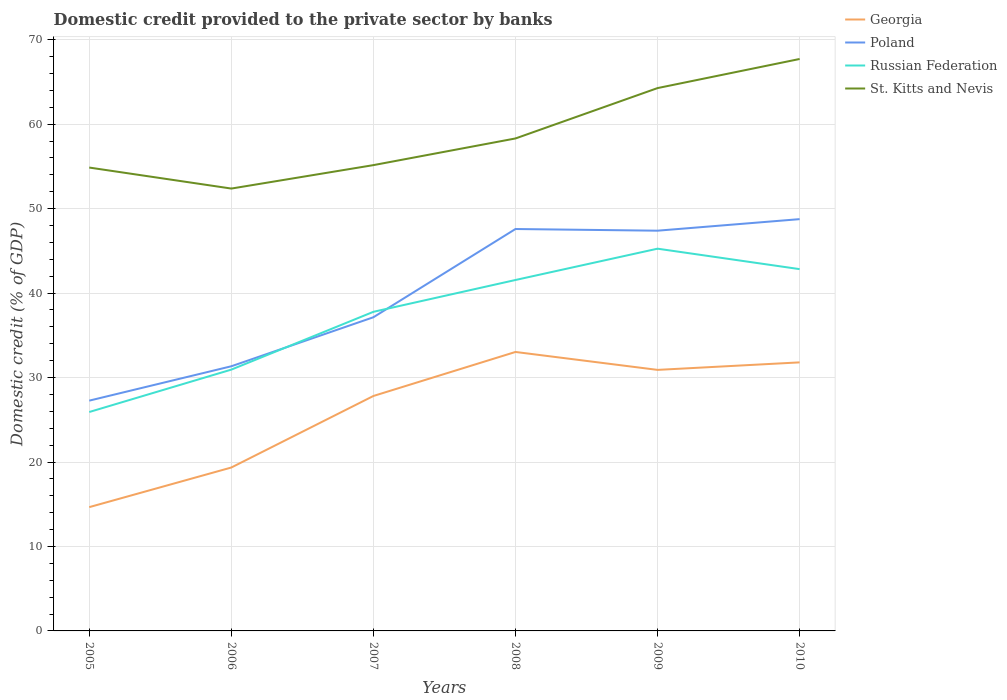Is the number of lines equal to the number of legend labels?
Your answer should be compact. Yes. Across all years, what is the maximum domestic credit provided to the private sector by banks in Georgia?
Provide a short and direct response. 14.66. In which year was the domestic credit provided to the private sector by banks in Poland maximum?
Make the answer very short. 2005. What is the total domestic credit provided to the private sector by banks in Georgia in the graph?
Keep it short and to the point. -13.16. What is the difference between the highest and the second highest domestic credit provided to the private sector by banks in St. Kitts and Nevis?
Keep it short and to the point. 15.34. What is the difference between two consecutive major ticks on the Y-axis?
Offer a terse response. 10. Are the values on the major ticks of Y-axis written in scientific E-notation?
Make the answer very short. No. Does the graph contain any zero values?
Your response must be concise. No. How are the legend labels stacked?
Offer a very short reply. Vertical. What is the title of the graph?
Your answer should be very brief. Domestic credit provided to the private sector by banks. Does "Croatia" appear as one of the legend labels in the graph?
Ensure brevity in your answer.  No. What is the label or title of the Y-axis?
Provide a succinct answer. Domestic credit (% of GDP). What is the Domestic credit (% of GDP) of Georgia in 2005?
Offer a terse response. 14.66. What is the Domestic credit (% of GDP) in Poland in 2005?
Keep it short and to the point. 27.27. What is the Domestic credit (% of GDP) in Russian Federation in 2005?
Offer a very short reply. 25.92. What is the Domestic credit (% of GDP) in St. Kitts and Nevis in 2005?
Ensure brevity in your answer.  54.86. What is the Domestic credit (% of GDP) in Georgia in 2006?
Make the answer very short. 19.35. What is the Domestic credit (% of GDP) in Poland in 2006?
Provide a short and direct response. 31.33. What is the Domestic credit (% of GDP) of Russian Federation in 2006?
Make the answer very short. 30.94. What is the Domestic credit (% of GDP) of St. Kitts and Nevis in 2006?
Ensure brevity in your answer.  52.38. What is the Domestic credit (% of GDP) of Georgia in 2007?
Give a very brief answer. 27.82. What is the Domestic credit (% of GDP) of Poland in 2007?
Your answer should be compact. 37.14. What is the Domestic credit (% of GDP) in Russian Federation in 2007?
Your answer should be compact. 37.78. What is the Domestic credit (% of GDP) in St. Kitts and Nevis in 2007?
Keep it short and to the point. 55.15. What is the Domestic credit (% of GDP) of Georgia in 2008?
Your response must be concise. 33.03. What is the Domestic credit (% of GDP) of Poland in 2008?
Offer a terse response. 47.59. What is the Domestic credit (% of GDP) of Russian Federation in 2008?
Offer a very short reply. 41.55. What is the Domestic credit (% of GDP) in St. Kitts and Nevis in 2008?
Your answer should be very brief. 58.31. What is the Domestic credit (% of GDP) of Georgia in 2009?
Your answer should be compact. 30.91. What is the Domestic credit (% of GDP) of Poland in 2009?
Your response must be concise. 47.39. What is the Domestic credit (% of GDP) in Russian Federation in 2009?
Make the answer very short. 45.26. What is the Domestic credit (% of GDP) of St. Kitts and Nevis in 2009?
Ensure brevity in your answer.  64.27. What is the Domestic credit (% of GDP) in Georgia in 2010?
Give a very brief answer. 31.8. What is the Domestic credit (% of GDP) of Poland in 2010?
Your answer should be very brief. 48.75. What is the Domestic credit (% of GDP) of Russian Federation in 2010?
Your answer should be very brief. 42.84. What is the Domestic credit (% of GDP) of St. Kitts and Nevis in 2010?
Offer a very short reply. 67.72. Across all years, what is the maximum Domestic credit (% of GDP) in Georgia?
Your answer should be very brief. 33.03. Across all years, what is the maximum Domestic credit (% of GDP) of Poland?
Provide a succinct answer. 48.75. Across all years, what is the maximum Domestic credit (% of GDP) in Russian Federation?
Ensure brevity in your answer.  45.26. Across all years, what is the maximum Domestic credit (% of GDP) in St. Kitts and Nevis?
Make the answer very short. 67.72. Across all years, what is the minimum Domestic credit (% of GDP) in Georgia?
Keep it short and to the point. 14.66. Across all years, what is the minimum Domestic credit (% of GDP) in Poland?
Provide a short and direct response. 27.27. Across all years, what is the minimum Domestic credit (% of GDP) in Russian Federation?
Give a very brief answer. 25.92. Across all years, what is the minimum Domestic credit (% of GDP) of St. Kitts and Nevis?
Your answer should be very brief. 52.38. What is the total Domestic credit (% of GDP) of Georgia in the graph?
Provide a succinct answer. 157.55. What is the total Domestic credit (% of GDP) of Poland in the graph?
Provide a short and direct response. 239.47. What is the total Domestic credit (% of GDP) in Russian Federation in the graph?
Offer a terse response. 224.28. What is the total Domestic credit (% of GDP) in St. Kitts and Nevis in the graph?
Give a very brief answer. 352.69. What is the difference between the Domestic credit (% of GDP) in Georgia in 2005 and that in 2006?
Your answer should be compact. -4.69. What is the difference between the Domestic credit (% of GDP) in Poland in 2005 and that in 2006?
Your answer should be very brief. -4.07. What is the difference between the Domestic credit (% of GDP) of Russian Federation in 2005 and that in 2006?
Ensure brevity in your answer.  -5.02. What is the difference between the Domestic credit (% of GDP) of St. Kitts and Nevis in 2005 and that in 2006?
Offer a very short reply. 2.49. What is the difference between the Domestic credit (% of GDP) in Georgia in 2005 and that in 2007?
Provide a short and direct response. -13.16. What is the difference between the Domestic credit (% of GDP) of Poland in 2005 and that in 2007?
Your response must be concise. -9.87. What is the difference between the Domestic credit (% of GDP) of Russian Federation in 2005 and that in 2007?
Offer a very short reply. -11.86. What is the difference between the Domestic credit (% of GDP) in St. Kitts and Nevis in 2005 and that in 2007?
Give a very brief answer. -0.29. What is the difference between the Domestic credit (% of GDP) in Georgia in 2005 and that in 2008?
Your response must be concise. -18.37. What is the difference between the Domestic credit (% of GDP) of Poland in 2005 and that in 2008?
Offer a very short reply. -20.32. What is the difference between the Domestic credit (% of GDP) of Russian Federation in 2005 and that in 2008?
Provide a succinct answer. -15.63. What is the difference between the Domestic credit (% of GDP) in St. Kitts and Nevis in 2005 and that in 2008?
Keep it short and to the point. -3.44. What is the difference between the Domestic credit (% of GDP) in Georgia in 2005 and that in 2009?
Make the answer very short. -16.25. What is the difference between the Domestic credit (% of GDP) in Poland in 2005 and that in 2009?
Offer a terse response. -20.12. What is the difference between the Domestic credit (% of GDP) in Russian Federation in 2005 and that in 2009?
Ensure brevity in your answer.  -19.34. What is the difference between the Domestic credit (% of GDP) in St. Kitts and Nevis in 2005 and that in 2009?
Give a very brief answer. -9.41. What is the difference between the Domestic credit (% of GDP) in Georgia in 2005 and that in 2010?
Keep it short and to the point. -17.14. What is the difference between the Domestic credit (% of GDP) of Poland in 2005 and that in 2010?
Give a very brief answer. -21.49. What is the difference between the Domestic credit (% of GDP) of Russian Federation in 2005 and that in 2010?
Provide a short and direct response. -16.92. What is the difference between the Domestic credit (% of GDP) in St. Kitts and Nevis in 2005 and that in 2010?
Give a very brief answer. -12.85. What is the difference between the Domestic credit (% of GDP) of Georgia in 2006 and that in 2007?
Your response must be concise. -8.47. What is the difference between the Domestic credit (% of GDP) of Poland in 2006 and that in 2007?
Offer a terse response. -5.8. What is the difference between the Domestic credit (% of GDP) of Russian Federation in 2006 and that in 2007?
Provide a short and direct response. -6.84. What is the difference between the Domestic credit (% of GDP) of St. Kitts and Nevis in 2006 and that in 2007?
Your answer should be very brief. -2.77. What is the difference between the Domestic credit (% of GDP) of Georgia in 2006 and that in 2008?
Provide a short and direct response. -13.68. What is the difference between the Domestic credit (% of GDP) in Poland in 2006 and that in 2008?
Provide a succinct answer. -16.25. What is the difference between the Domestic credit (% of GDP) in Russian Federation in 2006 and that in 2008?
Your answer should be very brief. -10.61. What is the difference between the Domestic credit (% of GDP) of St. Kitts and Nevis in 2006 and that in 2008?
Your answer should be very brief. -5.93. What is the difference between the Domestic credit (% of GDP) of Georgia in 2006 and that in 2009?
Keep it short and to the point. -11.56. What is the difference between the Domestic credit (% of GDP) of Poland in 2006 and that in 2009?
Provide a short and direct response. -16.05. What is the difference between the Domestic credit (% of GDP) of Russian Federation in 2006 and that in 2009?
Make the answer very short. -14.32. What is the difference between the Domestic credit (% of GDP) of St. Kitts and Nevis in 2006 and that in 2009?
Your answer should be very brief. -11.9. What is the difference between the Domestic credit (% of GDP) of Georgia in 2006 and that in 2010?
Keep it short and to the point. -12.45. What is the difference between the Domestic credit (% of GDP) of Poland in 2006 and that in 2010?
Your answer should be compact. -17.42. What is the difference between the Domestic credit (% of GDP) of Russian Federation in 2006 and that in 2010?
Ensure brevity in your answer.  -11.9. What is the difference between the Domestic credit (% of GDP) of St. Kitts and Nevis in 2006 and that in 2010?
Provide a succinct answer. -15.34. What is the difference between the Domestic credit (% of GDP) of Georgia in 2007 and that in 2008?
Make the answer very short. -5.21. What is the difference between the Domestic credit (% of GDP) in Poland in 2007 and that in 2008?
Your answer should be very brief. -10.45. What is the difference between the Domestic credit (% of GDP) in Russian Federation in 2007 and that in 2008?
Ensure brevity in your answer.  -3.77. What is the difference between the Domestic credit (% of GDP) of St. Kitts and Nevis in 2007 and that in 2008?
Your answer should be very brief. -3.16. What is the difference between the Domestic credit (% of GDP) in Georgia in 2007 and that in 2009?
Your answer should be compact. -3.09. What is the difference between the Domestic credit (% of GDP) of Poland in 2007 and that in 2009?
Your response must be concise. -10.25. What is the difference between the Domestic credit (% of GDP) in Russian Federation in 2007 and that in 2009?
Your answer should be very brief. -7.48. What is the difference between the Domestic credit (% of GDP) of St. Kitts and Nevis in 2007 and that in 2009?
Your answer should be compact. -9.12. What is the difference between the Domestic credit (% of GDP) in Georgia in 2007 and that in 2010?
Provide a succinct answer. -3.98. What is the difference between the Domestic credit (% of GDP) of Poland in 2007 and that in 2010?
Provide a succinct answer. -11.62. What is the difference between the Domestic credit (% of GDP) of Russian Federation in 2007 and that in 2010?
Your answer should be compact. -5.05. What is the difference between the Domestic credit (% of GDP) in St. Kitts and Nevis in 2007 and that in 2010?
Offer a very short reply. -12.57. What is the difference between the Domestic credit (% of GDP) in Georgia in 2008 and that in 2009?
Offer a very short reply. 2.12. What is the difference between the Domestic credit (% of GDP) in Poland in 2008 and that in 2009?
Provide a succinct answer. 0.2. What is the difference between the Domestic credit (% of GDP) of Russian Federation in 2008 and that in 2009?
Offer a very short reply. -3.71. What is the difference between the Domestic credit (% of GDP) of St. Kitts and Nevis in 2008 and that in 2009?
Offer a very short reply. -5.96. What is the difference between the Domestic credit (% of GDP) in Georgia in 2008 and that in 2010?
Offer a very short reply. 1.23. What is the difference between the Domestic credit (% of GDP) in Poland in 2008 and that in 2010?
Offer a very short reply. -1.17. What is the difference between the Domestic credit (% of GDP) of Russian Federation in 2008 and that in 2010?
Make the answer very short. -1.29. What is the difference between the Domestic credit (% of GDP) of St. Kitts and Nevis in 2008 and that in 2010?
Offer a very short reply. -9.41. What is the difference between the Domestic credit (% of GDP) of Georgia in 2009 and that in 2010?
Keep it short and to the point. -0.89. What is the difference between the Domestic credit (% of GDP) of Poland in 2009 and that in 2010?
Provide a succinct answer. -1.37. What is the difference between the Domestic credit (% of GDP) in Russian Federation in 2009 and that in 2010?
Give a very brief answer. 2.42. What is the difference between the Domestic credit (% of GDP) of St. Kitts and Nevis in 2009 and that in 2010?
Ensure brevity in your answer.  -3.45. What is the difference between the Domestic credit (% of GDP) in Georgia in 2005 and the Domestic credit (% of GDP) in Poland in 2006?
Offer a very short reply. -16.68. What is the difference between the Domestic credit (% of GDP) in Georgia in 2005 and the Domestic credit (% of GDP) in Russian Federation in 2006?
Ensure brevity in your answer.  -16.28. What is the difference between the Domestic credit (% of GDP) of Georgia in 2005 and the Domestic credit (% of GDP) of St. Kitts and Nevis in 2006?
Offer a very short reply. -37.72. What is the difference between the Domestic credit (% of GDP) in Poland in 2005 and the Domestic credit (% of GDP) in Russian Federation in 2006?
Provide a succinct answer. -3.67. What is the difference between the Domestic credit (% of GDP) of Poland in 2005 and the Domestic credit (% of GDP) of St. Kitts and Nevis in 2006?
Give a very brief answer. -25.11. What is the difference between the Domestic credit (% of GDP) of Russian Federation in 2005 and the Domestic credit (% of GDP) of St. Kitts and Nevis in 2006?
Keep it short and to the point. -26.46. What is the difference between the Domestic credit (% of GDP) in Georgia in 2005 and the Domestic credit (% of GDP) in Poland in 2007?
Your answer should be compact. -22.48. What is the difference between the Domestic credit (% of GDP) of Georgia in 2005 and the Domestic credit (% of GDP) of Russian Federation in 2007?
Provide a succinct answer. -23.13. What is the difference between the Domestic credit (% of GDP) in Georgia in 2005 and the Domestic credit (% of GDP) in St. Kitts and Nevis in 2007?
Your answer should be very brief. -40.49. What is the difference between the Domestic credit (% of GDP) in Poland in 2005 and the Domestic credit (% of GDP) in Russian Federation in 2007?
Give a very brief answer. -10.52. What is the difference between the Domestic credit (% of GDP) of Poland in 2005 and the Domestic credit (% of GDP) of St. Kitts and Nevis in 2007?
Offer a terse response. -27.89. What is the difference between the Domestic credit (% of GDP) in Russian Federation in 2005 and the Domestic credit (% of GDP) in St. Kitts and Nevis in 2007?
Your answer should be very brief. -29.23. What is the difference between the Domestic credit (% of GDP) of Georgia in 2005 and the Domestic credit (% of GDP) of Poland in 2008?
Your response must be concise. -32.93. What is the difference between the Domestic credit (% of GDP) in Georgia in 2005 and the Domestic credit (% of GDP) in Russian Federation in 2008?
Make the answer very short. -26.9. What is the difference between the Domestic credit (% of GDP) in Georgia in 2005 and the Domestic credit (% of GDP) in St. Kitts and Nevis in 2008?
Offer a very short reply. -43.65. What is the difference between the Domestic credit (% of GDP) in Poland in 2005 and the Domestic credit (% of GDP) in Russian Federation in 2008?
Your response must be concise. -14.29. What is the difference between the Domestic credit (% of GDP) of Poland in 2005 and the Domestic credit (% of GDP) of St. Kitts and Nevis in 2008?
Keep it short and to the point. -31.04. What is the difference between the Domestic credit (% of GDP) in Russian Federation in 2005 and the Domestic credit (% of GDP) in St. Kitts and Nevis in 2008?
Make the answer very short. -32.39. What is the difference between the Domestic credit (% of GDP) of Georgia in 2005 and the Domestic credit (% of GDP) of Poland in 2009?
Your response must be concise. -32.73. What is the difference between the Domestic credit (% of GDP) in Georgia in 2005 and the Domestic credit (% of GDP) in Russian Federation in 2009?
Offer a very short reply. -30.6. What is the difference between the Domestic credit (% of GDP) of Georgia in 2005 and the Domestic credit (% of GDP) of St. Kitts and Nevis in 2009?
Your answer should be compact. -49.62. What is the difference between the Domestic credit (% of GDP) in Poland in 2005 and the Domestic credit (% of GDP) in Russian Federation in 2009?
Provide a short and direct response. -17.99. What is the difference between the Domestic credit (% of GDP) of Poland in 2005 and the Domestic credit (% of GDP) of St. Kitts and Nevis in 2009?
Your answer should be compact. -37.01. What is the difference between the Domestic credit (% of GDP) of Russian Federation in 2005 and the Domestic credit (% of GDP) of St. Kitts and Nevis in 2009?
Offer a terse response. -38.35. What is the difference between the Domestic credit (% of GDP) in Georgia in 2005 and the Domestic credit (% of GDP) in Poland in 2010?
Ensure brevity in your answer.  -34.1. What is the difference between the Domestic credit (% of GDP) of Georgia in 2005 and the Domestic credit (% of GDP) of Russian Federation in 2010?
Your response must be concise. -28.18. What is the difference between the Domestic credit (% of GDP) of Georgia in 2005 and the Domestic credit (% of GDP) of St. Kitts and Nevis in 2010?
Offer a very short reply. -53.06. What is the difference between the Domestic credit (% of GDP) of Poland in 2005 and the Domestic credit (% of GDP) of Russian Federation in 2010?
Offer a terse response. -15.57. What is the difference between the Domestic credit (% of GDP) in Poland in 2005 and the Domestic credit (% of GDP) in St. Kitts and Nevis in 2010?
Your answer should be very brief. -40.45. What is the difference between the Domestic credit (% of GDP) in Russian Federation in 2005 and the Domestic credit (% of GDP) in St. Kitts and Nevis in 2010?
Your answer should be very brief. -41.8. What is the difference between the Domestic credit (% of GDP) of Georgia in 2006 and the Domestic credit (% of GDP) of Poland in 2007?
Give a very brief answer. -17.79. What is the difference between the Domestic credit (% of GDP) of Georgia in 2006 and the Domestic credit (% of GDP) of Russian Federation in 2007?
Ensure brevity in your answer.  -18.43. What is the difference between the Domestic credit (% of GDP) of Georgia in 2006 and the Domestic credit (% of GDP) of St. Kitts and Nevis in 2007?
Give a very brief answer. -35.8. What is the difference between the Domestic credit (% of GDP) of Poland in 2006 and the Domestic credit (% of GDP) of Russian Federation in 2007?
Ensure brevity in your answer.  -6.45. What is the difference between the Domestic credit (% of GDP) in Poland in 2006 and the Domestic credit (% of GDP) in St. Kitts and Nevis in 2007?
Offer a very short reply. -23.82. What is the difference between the Domestic credit (% of GDP) of Russian Federation in 2006 and the Domestic credit (% of GDP) of St. Kitts and Nevis in 2007?
Provide a short and direct response. -24.21. What is the difference between the Domestic credit (% of GDP) of Georgia in 2006 and the Domestic credit (% of GDP) of Poland in 2008?
Your answer should be very brief. -28.24. What is the difference between the Domestic credit (% of GDP) in Georgia in 2006 and the Domestic credit (% of GDP) in Russian Federation in 2008?
Offer a very short reply. -22.2. What is the difference between the Domestic credit (% of GDP) in Georgia in 2006 and the Domestic credit (% of GDP) in St. Kitts and Nevis in 2008?
Offer a terse response. -38.96. What is the difference between the Domestic credit (% of GDP) of Poland in 2006 and the Domestic credit (% of GDP) of Russian Federation in 2008?
Ensure brevity in your answer.  -10.22. What is the difference between the Domestic credit (% of GDP) of Poland in 2006 and the Domestic credit (% of GDP) of St. Kitts and Nevis in 2008?
Offer a terse response. -26.97. What is the difference between the Domestic credit (% of GDP) of Russian Federation in 2006 and the Domestic credit (% of GDP) of St. Kitts and Nevis in 2008?
Make the answer very short. -27.37. What is the difference between the Domestic credit (% of GDP) of Georgia in 2006 and the Domestic credit (% of GDP) of Poland in 2009?
Make the answer very short. -28.04. What is the difference between the Domestic credit (% of GDP) in Georgia in 2006 and the Domestic credit (% of GDP) in Russian Federation in 2009?
Provide a succinct answer. -25.91. What is the difference between the Domestic credit (% of GDP) in Georgia in 2006 and the Domestic credit (% of GDP) in St. Kitts and Nevis in 2009?
Give a very brief answer. -44.93. What is the difference between the Domestic credit (% of GDP) of Poland in 2006 and the Domestic credit (% of GDP) of Russian Federation in 2009?
Make the answer very short. -13.92. What is the difference between the Domestic credit (% of GDP) of Poland in 2006 and the Domestic credit (% of GDP) of St. Kitts and Nevis in 2009?
Provide a succinct answer. -32.94. What is the difference between the Domestic credit (% of GDP) of Russian Federation in 2006 and the Domestic credit (% of GDP) of St. Kitts and Nevis in 2009?
Your answer should be very brief. -33.33. What is the difference between the Domestic credit (% of GDP) in Georgia in 2006 and the Domestic credit (% of GDP) in Poland in 2010?
Your answer should be very brief. -29.41. What is the difference between the Domestic credit (% of GDP) in Georgia in 2006 and the Domestic credit (% of GDP) in Russian Federation in 2010?
Provide a short and direct response. -23.49. What is the difference between the Domestic credit (% of GDP) in Georgia in 2006 and the Domestic credit (% of GDP) in St. Kitts and Nevis in 2010?
Your response must be concise. -48.37. What is the difference between the Domestic credit (% of GDP) in Poland in 2006 and the Domestic credit (% of GDP) in Russian Federation in 2010?
Make the answer very short. -11.5. What is the difference between the Domestic credit (% of GDP) of Poland in 2006 and the Domestic credit (% of GDP) of St. Kitts and Nevis in 2010?
Give a very brief answer. -36.38. What is the difference between the Domestic credit (% of GDP) of Russian Federation in 2006 and the Domestic credit (% of GDP) of St. Kitts and Nevis in 2010?
Offer a terse response. -36.78. What is the difference between the Domestic credit (% of GDP) of Georgia in 2007 and the Domestic credit (% of GDP) of Poland in 2008?
Your answer should be very brief. -19.77. What is the difference between the Domestic credit (% of GDP) in Georgia in 2007 and the Domestic credit (% of GDP) in Russian Federation in 2008?
Your response must be concise. -13.73. What is the difference between the Domestic credit (% of GDP) of Georgia in 2007 and the Domestic credit (% of GDP) of St. Kitts and Nevis in 2008?
Offer a terse response. -30.49. What is the difference between the Domestic credit (% of GDP) in Poland in 2007 and the Domestic credit (% of GDP) in Russian Federation in 2008?
Offer a terse response. -4.41. What is the difference between the Domestic credit (% of GDP) in Poland in 2007 and the Domestic credit (% of GDP) in St. Kitts and Nevis in 2008?
Give a very brief answer. -21.17. What is the difference between the Domestic credit (% of GDP) of Russian Federation in 2007 and the Domestic credit (% of GDP) of St. Kitts and Nevis in 2008?
Your answer should be compact. -20.53. What is the difference between the Domestic credit (% of GDP) of Georgia in 2007 and the Domestic credit (% of GDP) of Poland in 2009?
Your answer should be compact. -19.57. What is the difference between the Domestic credit (% of GDP) of Georgia in 2007 and the Domestic credit (% of GDP) of Russian Federation in 2009?
Provide a short and direct response. -17.44. What is the difference between the Domestic credit (% of GDP) of Georgia in 2007 and the Domestic credit (% of GDP) of St. Kitts and Nevis in 2009?
Offer a terse response. -36.46. What is the difference between the Domestic credit (% of GDP) of Poland in 2007 and the Domestic credit (% of GDP) of Russian Federation in 2009?
Make the answer very short. -8.12. What is the difference between the Domestic credit (% of GDP) in Poland in 2007 and the Domestic credit (% of GDP) in St. Kitts and Nevis in 2009?
Your answer should be compact. -27.13. What is the difference between the Domestic credit (% of GDP) in Russian Federation in 2007 and the Domestic credit (% of GDP) in St. Kitts and Nevis in 2009?
Give a very brief answer. -26.49. What is the difference between the Domestic credit (% of GDP) in Georgia in 2007 and the Domestic credit (% of GDP) in Poland in 2010?
Keep it short and to the point. -20.94. What is the difference between the Domestic credit (% of GDP) in Georgia in 2007 and the Domestic credit (% of GDP) in Russian Federation in 2010?
Ensure brevity in your answer.  -15.02. What is the difference between the Domestic credit (% of GDP) in Georgia in 2007 and the Domestic credit (% of GDP) in St. Kitts and Nevis in 2010?
Make the answer very short. -39.9. What is the difference between the Domestic credit (% of GDP) of Poland in 2007 and the Domestic credit (% of GDP) of Russian Federation in 2010?
Your answer should be compact. -5.7. What is the difference between the Domestic credit (% of GDP) in Poland in 2007 and the Domestic credit (% of GDP) in St. Kitts and Nevis in 2010?
Keep it short and to the point. -30.58. What is the difference between the Domestic credit (% of GDP) of Russian Federation in 2007 and the Domestic credit (% of GDP) of St. Kitts and Nevis in 2010?
Provide a succinct answer. -29.94. What is the difference between the Domestic credit (% of GDP) in Georgia in 2008 and the Domestic credit (% of GDP) in Poland in 2009?
Your answer should be compact. -14.36. What is the difference between the Domestic credit (% of GDP) of Georgia in 2008 and the Domestic credit (% of GDP) of Russian Federation in 2009?
Keep it short and to the point. -12.23. What is the difference between the Domestic credit (% of GDP) of Georgia in 2008 and the Domestic credit (% of GDP) of St. Kitts and Nevis in 2009?
Your response must be concise. -31.24. What is the difference between the Domestic credit (% of GDP) of Poland in 2008 and the Domestic credit (% of GDP) of Russian Federation in 2009?
Your answer should be very brief. 2.33. What is the difference between the Domestic credit (% of GDP) in Poland in 2008 and the Domestic credit (% of GDP) in St. Kitts and Nevis in 2009?
Offer a very short reply. -16.69. What is the difference between the Domestic credit (% of GDP) of Russian Federation in 2008 and the Domestic credit (% of GDP) of St. Kitts and Nevis in 2009?
Provide a succinct answer. -22.72. What is the difference between the Domestic credit (% of GDP) of Georgia in 2008 and the Domestic credit (% of GDP) of Poland in 2010?
Give a very brief answer. -15.73. What is the difference between the Domestic credit (% of GDP) of Georgia in 2008 and the Domestic credit (% of GDP) of Russian Federation in 2010?
Provide a short and direct response. -9.81. What is the difference between the Domestic credit (% of GDP) of Georgia in 2008 and the Domestic credit (% of GDP) of St. Kitts and Nevis in 2010?
Provide a short and direct response. -34.69. What is the difference between the Domestic credit (% of GDP) in Poland in 2008 and the Domestic credit (% of GDP) in Russian Federation in 2010?
Keep it short and to the point. 4.75. What is the difference between the Domestic credit (% of GDP) in Poland in 2008 and the Domestic credit (% of GDP) in St. Kitts and Nevis in 2010?
Your response must be concise. -20.13. What is the difference between the Domestic credit (% of GDP) of Russian Federation in 2008 and the Domestic credit (% of GDP) of St. Kitts and Nevis in 2010?
Give a very brief answer. -26.17. What is the difference between the Domestic credit (% of GDP) in Georgia in 2009 and the Domestic credit (% of GDP) in Poland in 2010?
Ensure brevity in your answer.  -17.85. What is the difference between the Domestic credit (% of GDP) in Georgia in 2009 and the Domestic credit (% of GDP) in Russian Federation in 2010?
Your response must be concise. -11.93. What is the difference between the Domestic credit (% of GDP) in Georgia in 2009 and the Domestic credit (% of GDP) in St. Kitts and Nevis in 2010?
Provide a short and direct response. -36.81. What is the difference between the Domestic credit (% of GDP) of Poland in 2009 and the Domestic credit (% of GDP) of Russian Federation in 2010?
Your answer should be very brief. 4.55. What is the difference between the Domestic credit (% of GDP) in Poland in 2009 and the Domestic credit (% of GDP) in St. Kitts and Nevis in 2010?
Provide a short and direct response. -20.33. What is the difference between the Domestic credit (% of GDP) in Russian Federation in 2009 and the Domestic credit (% of GDP) in St. Kitts and Nevis in 2010?
Provide a succinct answer. -22.46. What is the average Domestic credit (% of GDP) in Georgia per year?
Your answer should be very brief. 26.26. What is the average Domestic credit (% of GDP) in Poland per year?
Ensure brevity in your answer.  39.91. What is the average Domestic credit (% of GDP) of Russian Federation per year?
Your answer should be very brief. 37.38. What is the average Domestic credit (% of GDP) of St. Kitts and Nevis per year?
Provide a short and direct response. 58.78. In the year 2005, what is the difference between the Domestic credit (% of GDP) of Georgia and Domestic credit (% of GDP) of Poland?
Your response must be concise. -12.61. In the year 2005, what is the difference between the Domestic credit (% of GDP) in Georgia and Domestic credit (% of GDP) in Russian Federation?
Give a very brief answer. -11.26. In the year 2005, what is the difference between the Domestic credit (% of GDP) of Georgia and Domestic credit (% of GDP) of St. Kitts and Nevis?
Offer a very short reply. -40.21. In the year 2005, what is the difference between the Domestic credit (% of GDP) in Poland and Domestic credit (% of GDP) in Russian Federation?
Your answer should be compact. 1.35. In the year 2005, what is the difference between the Domestic credit (% of GDP) of Poland and Domestic credit (% of GDP) of St. Kitts and Nevis?
Offer a terse response. -27.6. In the year 2005, what is the difference between the Domestic credit (% of GDP) of Russian Federation and Domestic credit (% of GDP) of St. Kitts and Nevis?
Ensure brevity in your answer.  -28.95. In the year 2006, what is the difference between the Domestic credit (% of GDP) of Georgia and Domestic credit (% of GDP) of Poland?
Give a very brief answer. -11.99. In the year 2006, what is the difference between the Domestic credit (% of GDP) of Georgia and Domestic credit (% of GDP) of Russian Federation?
Keep it short and to the point. -11.59. In the year 2006, what is the difference between the Domestic credit (% of GDP) in Georgia and Domestic credit (% of GDP) in St. Kitts and Nevis?
Offer a terse response. -33.03. In the year 2006, what is the difference between the Domestic credit (% of GDP) of Poland and Domestic credit (% of GDP) of Russian Federation?
Give a very brief answer. 0.4. In the year 2006, what is the difference between the Domestic credit (% of GDP) in Poland and Domestic credit (% of GDP) in St. Kitts and Nevis?
Your answer should be compact. -21.04. In the year 2006, what is the difference between the Domestic credit (% of GDP) in Russian Federation and Domestic credit (% of GDP) in St. Kitts and Nevis?
Ensure brevity in your answer.  -21.44. In the year 2007, what is the difference between the Domestic credit (% of GDP) of Georgia and Domestic credit (% of GDP) of Poland?
Your answer should be compact. -9.32. In the year 2007, what is the difference between the Domestic credit (% of GDP) of Georgia and Domestic credit (% of GDP) of Russian Federation?
Your answer should be compact. -9.97. In the year 2007, what is the difference between the Domestic credit (% of GDP) in Georgia and Domestic credit (% of GDP) in St. Kitts and Nevis?
Keep it short and to the point. -27.33. In the year 2007, what is the difference between the Domestic credit (% of GDP) in Poland and Domestic credit (% of GDP) in Russian Federation?
Your answer should be compact. -0.64. In the year 2007, what is the difference between the Domestic credit (% of GDP) of Poland and Domestic credit (% of GDP) of St. Kitts and Nevis?
Ensure brevity in your answer.  -18.01. In the year 2007, what is the difference between the Domestic credit (% of GDP) of Russian Federation and Domestic credit (% of GDP) of St. Kitts and Nevis?
Offer a very short reply. -17.37. In the year 2008, what is the difference between the Domestic credit (% of GDP) in Georgia and Domestic credit (% of GDP) in Poland?
Offer a very short reply. -14.56. In the year 2008, what is the difference between the Domestic credit (% of GDP) in Georgia and Domestic credit (% of GDP) in Russian Federation?
Give a very brief answer. -8.52. In the year 2008, what is the difference between the Domestic credit (% of GDP) of Georgia and Domestic credit (% of GDP) of St. Kitts and Nevis?
Ensure brevity in your answer.  -25.28. In the year 2008, what is the difference between the Domestic credit (% of GDP) of Poland and Domestic credit (% of GDP) of Russian Federation?
Make the answer very short. 6.04. In the year 2008, what is the difference between the Domestic credit (% of GDP) in Poland and Domestic credit (% of GDP) in St. Kitts and Nevis?
Offer a very short reply. -10.72. In the year 2008, what is the difference between the Domestic credit (% of GDP) of Russian Federation and Domestic credit (% of GDP) of St. Kitts and Nevis?
Your response must be concise. -16.76. In the year 2009, what is the difference between the Domestic credit (% of GDP) of Georgia and Domestic credit (% of GDP) of Poland?
Provide a short and direct response. -16.48. In the year 2009, what is the difference between the Domestic credit (% of GDP) in Georgia and Domestic credit (% of GDP) in Russian Federation?
Your response must be concise. -14.35. In the year 2009, what is the difference between the Domestic credit (% of GDP) of Georgia and Domestic credit (% of GDP) of St. Kitts and Nevis?
Offer a very short reply. -33.37. In the year 2009, what is the difference between the Domestic credit (% of GDP) in Poland and Domestic credit (% of GDP) in Russian Federation?
Give a very brief answer. 2.13. In the year 2009, what is the difference between the Domestic credit (% of GDP) of Poland and Domestic credit (% of GDP) of St. Kitts and Nevis?
Provide a succinct answer. -16.88. In the year 2009, what is the difference between the Domestic credit (% of GDP) of Russian Federation and Domestic credit (% of GDP) of St. Kitts and Nevis?
Provide a short and direct response. -19.01. In the year 2010, what is the difference between the Domestic credit (% of GDP) of Georgia and Domestic credit (% of GDP) of Poland?
Offer a terse response. -16.96. In the year 2010, what is the difference between the Domestic credit (% of GDP) of Georgia and Domestic credit (% of GDP) of Russian Federation?
Ensure brevity in your answer.  -11.04. In the year 2010, what is the difference between the Domestic credit (% of GDP) in Georgia and Domestic credit (% of GDP) in St. Kitts and Nevis?
Offer a very short reply. -35.92. In the year 2010, what is the difference between the Domestic credit (% of GDP) in Poland and Domestic credit (% of GDP) in Russian Federation?
Your answer should be very brief. 5.92. In the year 2010, what is the difference between the Domestic credit (% of GDP) in Poland and Domestic credit (% of GDP) in St. Kitts and Nevis?
Your response must be concise. -18.96. In the year 2010, what is the difference between the Domestic credit (% of GDP) in Russian Federation and Domestic credit (% of GDP) in St. Kitts and Nevis?
Make the answer very short. -24.88. What is the ratio of the Domestic credit (% of GDP) in Georgia in 2005 to that in 2006?
Your answer should be very brief. 0.76. What is the ratio of the Domestic credit (% of GDP) in Poland in 2005 to that in 2006?
Make the answer very short. 0.87. What is the ratio of the Domestic credit (% of GDP) in Russian Federation in 2005 to that in 2006?
Provide a succinct answer. 0.84. What is the ratio of the Domestic credit (% of GDP) in St. Kitts and Nevis in 2005 to that in 2006?
Your answer should be compact. 1.05. What is the ratio of the Domestic credit (% of GDP) in Georgia in 2005 to that in 2007?
Ensure brevity in your answer.  0.53. What is the ratio of the Domestic credit (% of GDP) of Poland in 2005 to that in 2007?
Offer a terse response. 0.73. What is the ratio of the Domestic credit (% of GDP) in Russian Federation in 2005 to that in 2007?
Provide a short and direct response. 0.69. What is the ratio of the Domestic credit (% of GDP) of St. Kitts and Nevis in 2005 to that in 2007?
Ensure brevity in your answer.  0.99. What is the ratio of the Domestic credit (% of GDP) of Georgia in 2005 to that in 2008?
Ensure brevity in your answer.  0.44. What is the ratio of the Domestic credit (% of GDP) of Poland in 2005 to that in 2008?
Offer a terse response. 0.57. What is the ratio of the Domestic credit (% of GDP) in Russian Federation in 2005 to that in 2008?
Your response must be concise. 0.62. What is the ratio of the Domestic credit (% of GDP) of St. Kitts and Nevis in 2005 to that in 2008?
Ensure brevity in your answer.  0.94. What is the ratio of the Domestic credit (% of GDP) in Georgia in 2005 to that in 2009?
Provide a succinct answer. 0.47. What is the ratio of the Domestic credit (% of GDP) in Poland in 2005 to that in 2009?
Keep it short and to the point. 0.58. What is the ratio of the Domestic credit (% of GDP) of Russian Federation in 2005 to that in 2009?
Offer a terse response. 0.57. What is the ratio of the Domestic credit (% of GDP) in St. Kitts and Nevis in 2005 to that in 2009?
Make the answer very short. 0.85. What is the ratio of the Domestic credit (% of GDP) of Georgia in 2005 to that in 2010?
Your answer should be very brief. 0.46. What is the ratio of the Domestic credit (% of GDP) of Poland in 2005 to that in 2010?
Your response must be concise. 0.56. What is the ratio of the Domestic credit (% of GDP) of Russian Federation in 2005 to that in 2010?
Your response must be concise. 0.61. What is the ratio of the Domestic credit (% of GDP) of St. Kitts and Nevis in 2005 to that in 2010?
Your response must be concise. 0.81. What is the ratio of the Domestic credit (% of GDP) in Georgia in 2006 to that in 2007?
Provide a short and direct response. 0.7. What is the ratio of the Domestic credit (% of GDP) of Poland in 2006 to that in 2007?
Offer a terse response. 0.84. What is the ratio of the Domestic credit (% of GDP) of Russian Federation in 2006 to that in 2007?
Give a very brief answer. 0.82. What is the ratio of the Domestic credit (% of GDP) of St. Kitts and Nevis in 2006 to that in 2007?
Your response must be concise. 0.95. What is the ratio of the Domestic credit (% of GDP) in Georgia in 2006 to that in 2008?
Give a very brief answer. 0.59. What is the ratio of the Domestic credit (% of GDP) of Poland in 2006 to that in 2008?
Your response must be concise. 0.66. What is the ratio of the Domestic credit (% of GDP) of Russian Federation in 2006 to that in 2008?
Make the answer very short. 0.74. What is the ratio of the Domestic credit (% of GDP) of St. Kitts and Nevis in 2006 to that in 2008?
Make the answer very short. 0.9. What is the ratio of the Domestic credit (% of GDP) in Georgia in 2006 to that in 2009?
Offer a very short reply. 0.63. What is the ratio of the Domestic credit (% of GDP) of Poland in 2006 to that in 2009?
Ensure brevity in your answer.  0.66. What is the ratio of the Domestic credit (% of GDP) in Russian Federation in 2006 to that in 2009?
Keep it short and to the point. 0.68. What is the ratio of the Domestic credit (% of GDP) in St. Kitts and Nevis in 2006 to that in 2009?
Make the answer very short. 0.81. What is the ratio of the Domestic credit (% of GDP) in Georgia in 2006 to that in 2010?
Offer a terse response. 0.61. What is the ratio of the Domestic credit (% of GDP) of Poland in 2006 to that in 2010?
Ensure brevity in your answer.  0.64. What is the ratio of the Domestic credit (% of GDP) in Russian Federation in 2006 to that in 2010?
Keep it short and to the point. 0.72. What is the ratio of the Domestic credit (% of GDP) of St. Kitts and Nevis in 2006 to that in 2010?
Offer a terse response. 0.77. What is the ratio of the Domestic credit (% of GDP) of Georgia in 2007 to that in 2008?
Keep it short and to the point. 0.84. What is the ratio of the Domestic credit (% of GDP) of Poland in 2007 to that in 2008?
Your answer should be compact. 0.78. What is the ratio of the Domestic credit (% of GDP) of Russian Federation in 2007 to that in 2008?
Keep it short and to the point. 0.91. What is the ratio of the Domestic credit (% of GDP) of St. Kitts and Nevis in 2007 to that in 2008?
Your response must be concise. 0.95. What is the ratio of the Domestic credit (% of GDP) of Poland in 2007 to that in 2009?
Provide a succinct answer. 0.78. What is the ratio of the Domestic credit (% of GDP) of Russian Federation in 2007 to that in 2009?
Offer a very short reply. 0.83. What is the ratio of the Domestic credit (% of GDP) in St. Kitts and Nevis in 2007 to that in 2009?
Your answer should be very brief. 0.86. What is the ratio of the Domestic credit (% of GDP) of Georgia in 2007 to that in 2010?
Offer a terse response. 0.87. What is the ratio of the Domestic credit (% of GDP) in Poland in 2007 to that in 2010?
Ensure brevity in your answer.  0.76. What is the ratio of the Domestic credit (% of GDP) in Russian Federation in 2007 to that in 2010?
Provide a short and direct response. 0.88. What is the ratio of the Domestic credit (% of GDP) of St. Kitts and Nevis in 2007 to that in 2010?
Ensure brevity in your answer.  0.81. What is the ratio of the Domestic credit (% of GDP) in Georgia in 2008 to that in 2009?
Offer a terse response. 1.07. What is the ratio of the Domestic credit (% of GDP) of Russian Federation in 2008 to that in 2009?
Offer a terse response. 0.92. What is the ratio of the Domestic credit (% of GDP) in St. Kitts and Nevis in 2008 to that in 2009?
Your answer should be very brief. 0.91. What is the ratio of the Domestic credit (% of GDP) in Georgia in 2008 to that in 2010?
Your answer should be very brief. 1.04. What is the ratio of the Domestic credit (% of GDP) of Poland in 2008 to that in 2010?
Give a very brief answer. 0.98. What is the ratio of the Domestic credit (% of GDP) in Russian Federation in 2008 to that in 2010?
Give a very brief answer. 0.97. What is the ratio of the Domestic credit (% of GDP) of St. Kitts and Nevis in 2008 to that in 2010?
Keep it short and to the point. 0.86. What is the ratio of the Domestic credit (% of GDP) of Georgia in 2009 to that in 2010?
Give a very brief answer. 0.97. What is the ratio of the Domestic credit (% of GDP) in Poland in 2009 to that in 2010?
Your answer should be very brief. 0.97. What is the ratio of the Domestic credit (% of GDP) in Russian Federation in 2009 to that in 2010?
Provide a succinct answer. 1.06. What is the ratio of the Domestic credit (% of GDP) in St. Kitts and Nevis in 2009 to that in 2010?
Offer a very short reply. 0.95. What is the difference between the highest and the second highest Domestic credit (% of GDP) in Georgia?
Ensure brevity in your answer.  1.23. What is the difference between the highest and the second highest Domestic credit (% of GDP) in Poland?
Provide a short and direct response. 1.17. What is the difference between the highest and the second highest Domestic credit (% of GDP) of Russian Federation?
Ensure brevity in your answer.  2.42. What is the difference between the highest and the second highest Domestic credit (% of GDP) in St. Kitts and Nevis?
Provide a succinct answer. 3.45. What is the difference between the highest and the lowest Domestic credit (% of GDP) of Georgia?
Keep it short and to the point. 18.37. What is the difference between the highest and the lowest Domestic credit (% of GDP) of Poland?
Your answer should be very brief. 21.49. What is the difference between the highest and the lowest Domestic credit (% of GDP) of Russian Federation?
Provide a succinct answer. 19.34. What is the difference between the highest and the lowest Domestic credit (% of GDP) in St. Kitts and Nevis?
Provide a short and direct response. 15.34. 